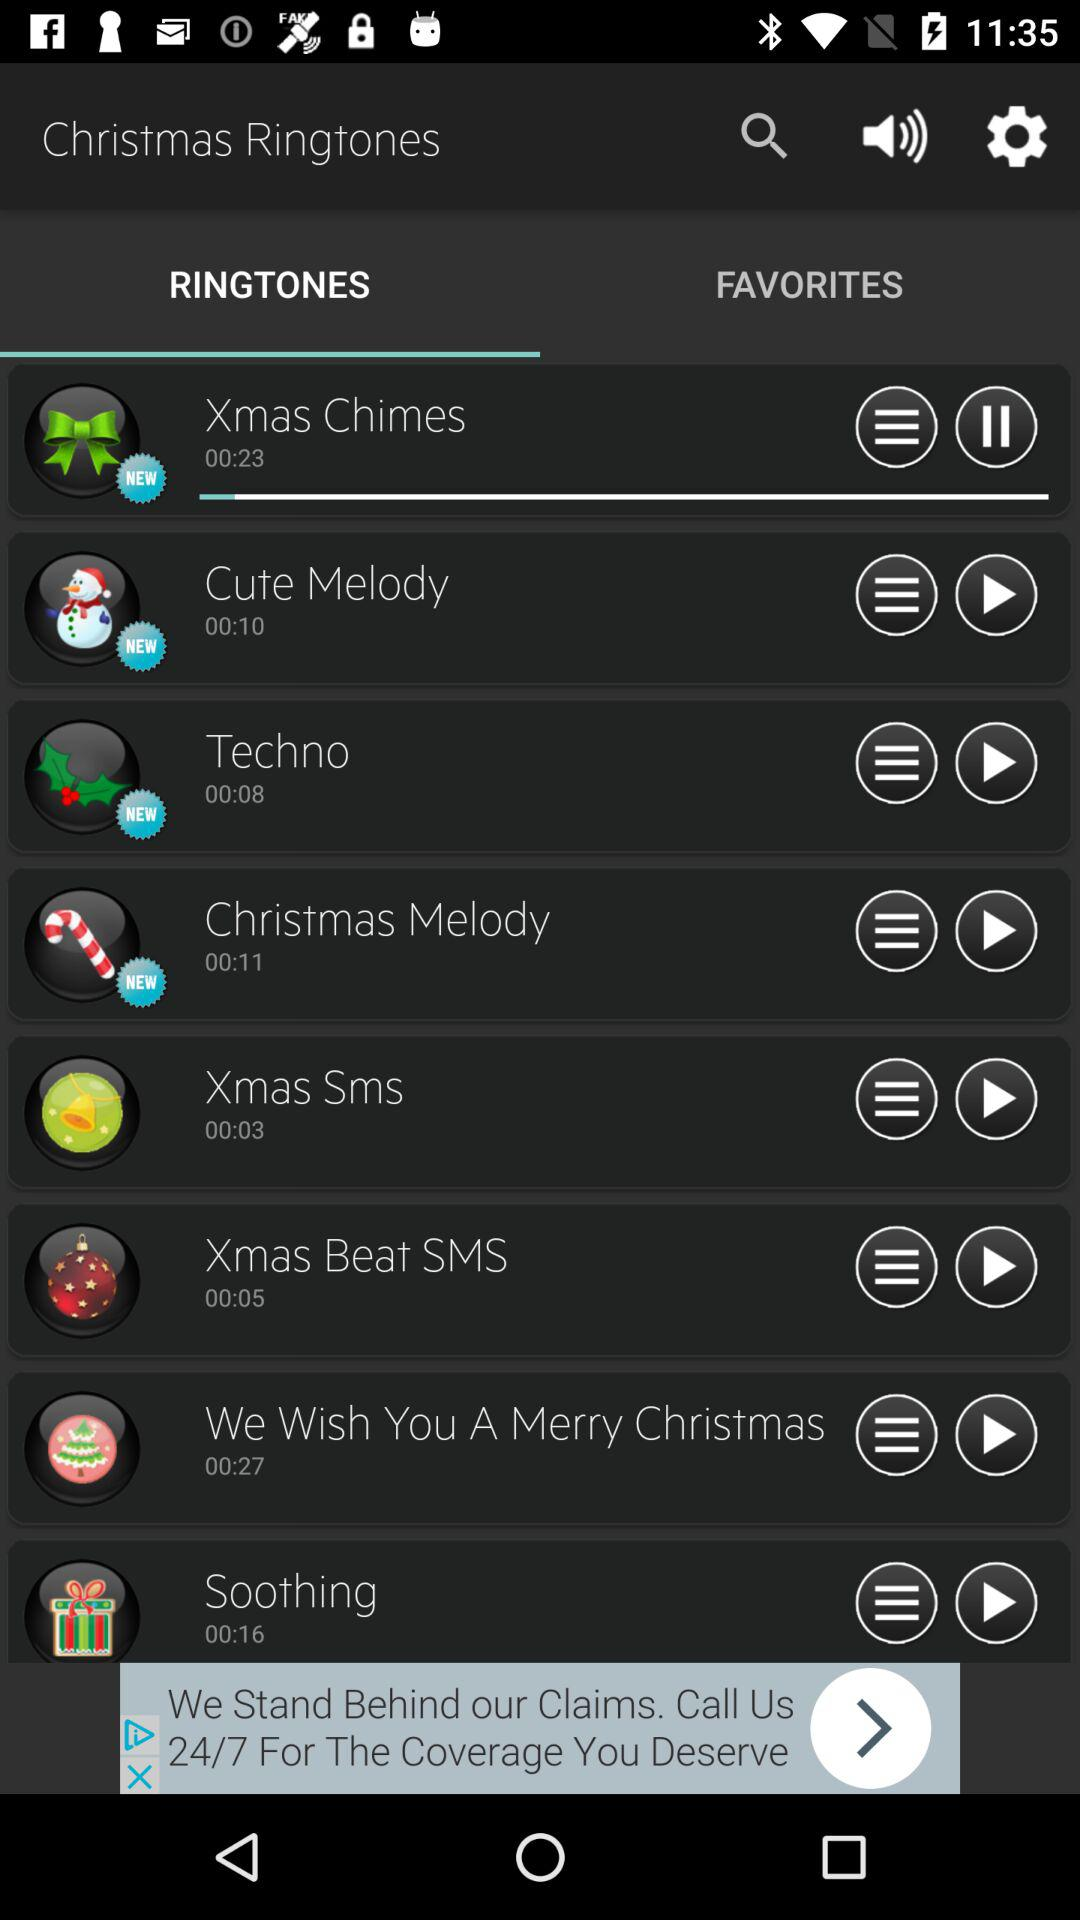How long is the longest ringtone?
Answer the question using a single word or phrase. 00:27 